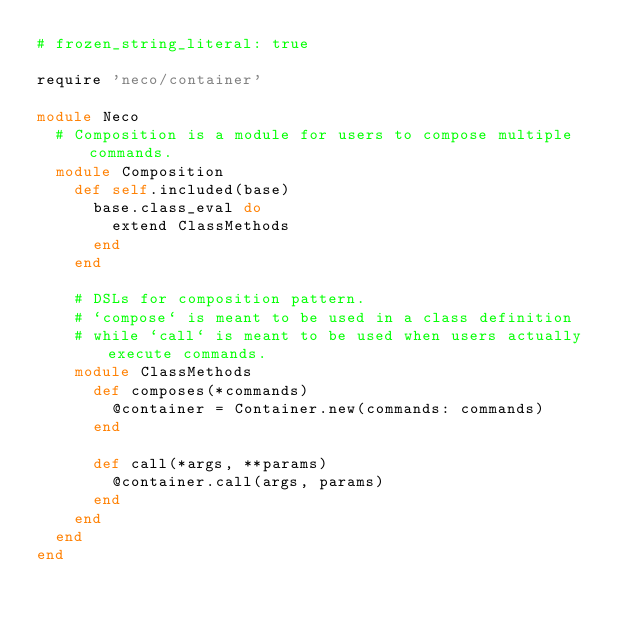<code> <loc_0><loc_0><loc_500><loc_500><_Ruby_># frozen_string_literal: true

require 'neco/container'

module Neco
  # Composition is a module for users to compose multiple commands.
  module Composition
    def self.included(base)
      base.class_eval do
        extend ClassMethods
      end
    end

    # DSLs for composition pattern.
    # `compose` is meant to be used in a class definition
    # while `call` is meant to be used when users actually execute commands.
    module ClassMethods
      def composes(*commands)
        @container = Container.new(commands: commands)
      end

      def call(*args, **params)
        @container.call(args, params)
      end
    end
  end
end
</code> 